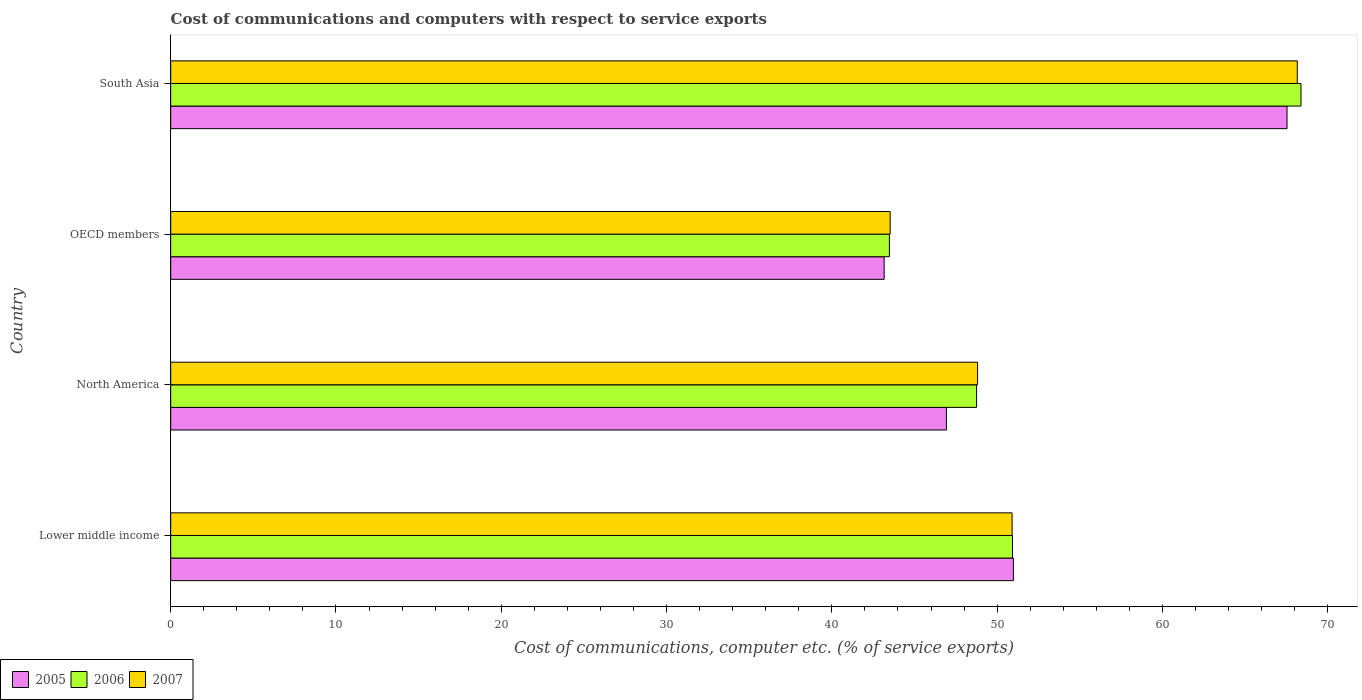How many different coloured bars are there?
Your answer should be compact. 3. How many groups of bars are there?
Provide a short and direct response. 4. Are the number of bars per tick equal to the number of legend labels?
Offer a terse response. Yes. What is the label of the 4th group of bars from the top?
Your answer should be compact. Lower middle income. What is the cost of communications and computers in 2005 in Lower middle income?
Give a very brief answer. 50.99. Across all countries, what is the maximum cost of communications and computers in 2007?
Offer a terse response. 68.16. Across all countries, what is the minimum cost of communications and computers in 2007?
Provide a succinct answer. 43.53. In which country was the cost of communications and computers in 2006 maximum?
Your response must be concise. South Asia. In which country was the cost of communications and computers in 2006 minimum?
Your answer should be compact. OECD members. What is the total cost of communications and computers in 2006 in the graph?
Offer a terse response. 211.55. What is the difference between the cost of communications and computers in 2005 in Lower middle income and that in North America?
Provide a succinct answer. 4.05. What is the difference between the cost of communications and computers in 2005 in Lower middle income and the cost of communications and computers in 2006 in OECD members?
Offer a terse response. 7.5. What is the average cost of communications and computers in 2006 per country?
Your answer should be compact. 52.89. What is the difference between the cost of communications and computers in 2007 and cost of communications and computers in 2005 in Lower middle income?
Provide a succinct answer. -0.08. What is the ratio of the cost of communications and computers in 2007 in Lower middle income to that in OECD members?
Your answer should be compact. 1.17. Is the cost of communications and computers in 2005 in North America less than that in South Asia?
Your answer should be compact. Yes. Is the difference between the cost of communications and computers in 2007 in OECD members and South Asia greater than the difference between the cost of communications and computers in 2005 in OECD members and South Asia?
Provide a succinct answer. No. What is the difference between the highest and the second highest cost of communications and computers in 2007?
Offer a very short reply. 17.25. What is the difference between the highest and the lowest cost of communications and computers in 2005?
Give a very brief answer. 24.37. Is the sum of the cost of communications and computers in 2006 in Lower middle income and South Asia greater than the maximum cost of communications and computers in 2005 across all countries?
Offer a very short reply. Yes. What does the 2nd bar from the bottom in Lower middle income represents?
Provide a short and direct response. 2006. How many bars are there?
Your answer should be very brief. 12. Are all the bars in the graph horizontal?
Ensure brevity in your answer.  Yes. How many countries are there in the graph?
Provide a succinct answer. 4. What is the difference between two consecutive major ticks on the X-axis?
Keep it short and to the point. 10. Are the values on the major ticks of X-axis written in scientific E-notation?
Provide a succinct answer. No. Does the graph contain any zero values?
Offer a very short reply. No. What is the title of the graph?
Offer a very short reply. Cost of communications and computers with respect to service exports. Does "2011" appear as one of the legend labels in the graph?
Provide a short and direct response. No. What is the label or title of the X-axis?
Offer a very short reply. Cost of communications, computer etc. (% of service exports). What is the label or title of the Y-axis?
Your answer should be compact. Country. What is the Cost of communications, computer etc. (% of service exports) in 2005 in Lower middle income?
Offer a terse response. 50.99. What is the Cost of communications, computer etc. (% of service exports) in 2006 in Lower middle income?
Keep it short and to the point. 50.93. What is the Cost of communications, computer etc. (% of service exports) of 2007 in Lower middle income?
Your answer should be very brief. 50.91. What is the Cost of communications, computer etc. (% of service exports) in 2005 in North America?
Your answer should be compact. 46.93. What is the Cost of communications, computer etc. (% of service exports) in 2006 in North America?
Your response must be concise. 48.76. What is the Cost of communications, computer etc. (% of service exports) in 2007 in North America?
Make the answer very short. 48.82. What is the Cost of communications, computer etc. (% of service exports) in 2005 in OECD members?
Your answer should be very brief. 43.17. What is the Cost of communications, computer etc. (% of service exports) of 2006 in OECD members?
Make the answer very short. 43.48. What is the Cost of communications, computer etc. (% of service exports) in 2007 in OECD members?
Provide a succinct answer. 43.53. What is the Cost of communications, computer etc. (% of service exports) in 2005 in South Asia?
Make the answer very short. 67.54. What is the Cost of communications, computer etc. (% of service exports) of 2006 in South Asia?
Your response must be concise. 68.39. What is the Cost of communications, computer etc. (% of service exports) in 2007 in South Asia?
Your answer should be very brief. 68.16. Across all countries, what is the maximum Cost of communications, computer etc. (% of service exports) in 2005?
Offer a very short reply. 67.54. Across all countries, what is the maximum Cost of communications, computer etc. (% of service exports) of 2006?
Your response must be concise. 68.39. Across all countries, what is the maximum Cost of communications, computer etc. (% of service exports) of 2007?
Ensure brevity in your answer.  68.16. Across all countries, what is the minimum Cost of communications, computer etc. (% of service exports) in 2005?
Provide a succinct answer. 43.17. Across all countries, what is the minimum Cost of communications, computer etc. (% of service exports) in 2006?
Keep it short and to the point. 43.48. Across all countries, what is the minimum Cost of communications, computer etc. (% of service exports) in 2007?
Provide a succinct answer. 43.53. What is the total Cost of communications, computer etc. (% of service exports) of 2005 in the graph?
Provide a short and direct response. 208.63. What is the total Cost of communications, computer etc. (% of service exports) of 2006 in the graph?
Ensure brevity in your answer.  211.55. What is the total Cost of communications, computer etc. (% of service exports) of 2007 in the graph?
Your response must be concise. 211.41. What is the difference between the Cost of communications, computer etc. (% of service exports) in 2005 in Lower middle income and that in North America?
Your answer should be very brief. 4.05. What is the difference between the Cost of communications, computer etc. (% of service exports) of 2006 in Lower middle income and that in North America?
Offer a very short reply. 2.17. What is the difference between the Cost of communications, computer etc. (% of service exports) in 2007 in Lower middle income and that in North America?
Your answer should be compact. 2.09. What is the difference between the Cost of communications, computer etc. (% of service exports) in 2005 in Lower middle income and that in OECD members?
Provide a succinct answer. 7.82. What is the difference between the Cost of communications, computer etc. (% of service exports) in 2006 in Lower middle income and that in OECD members?
Provide a succinct answer. 7.45. What is the difference between the Cost of communications, computer etc. (% of service exports) in 2007 in Lower middle income and that in OECD members?
Provide a short and direct response. 7.38. What is the difference between the Cost of communications, computer etc. (% of service exports) of 2005 in Lower middle income and that in South Asia?
Give a very brief answer. -16.55. What is the difference between the Cost of communications, computer etc. (% of service exports) in 2006 in Lower middle income and that in South Asia?
Your response must be concise. -17.45. What is the difference between the Cost of communications, computer etc. (% of service exports) in 2007 in Lower middle income and that in South Asia?
Provide a succinct answer. -17.25. What is the difference between the Cost of communications, computer etc. (% of service exports) of 2005 in North America and that in OECD members?
Give a very brief answer. 3.77. What is the difference between the Cost of communications, computer etc. (% of service exports) of 2006 in North America and that in OECD members?
Provide a short and direct response. 5.28. What is the difference between the Cost of communications, computer etc. (% of service exports) of 2007 in North America and that in OECD members?
Offer a very short reply. 5.29. What is the difference between the Cost of communications, computer etc. (% of service exports) of 2005 in North America and that in South Asia?
Your answer should be very brief. -20.61. What is the difference between the Cost of communications, computer etc. (% of service exports) of 2006 in North America and that in South Asia?
Your response must be concise. -19.63. What is the difference between the Cost of communications, computer etc. (% of service exports) in 2007 in North America and that in South Asia?
Your response must be concise. -19.34. What is the difference between the Cost of communications, computer etc. (% of service exports) of 2005 in OECD members and that in South Asia?
Your answer should be very brief. -24.37. What is the difference between the Cost of communications, computer etc. (% of service exports) in 2006 in OECD members and that in South Asia?
Make the answer very short. -24.9. What is the difference between the Cost of communications, computer etc. (% of service exports) of 2007 in OECD members and that in South Asia?
Your answer should be compact. -24.63. What is the difference between the Cost of communications, computer etc. (% of service exports) in 2005 in Lower middle income and the Cost of communications, computer etc. (% of service exports) in 2006 in North America?
Offer a terse response. 2.23. What is the difference between the Cost of communications, computer etc. (% of service exports) of 2005 in Lower middle income and the Cost of communications, computer etc. (% of service exports) of 2007 in North America?
Ensure brevity in your answer.  2.17. What is the difference between the Cost of communications, computer etc. (% of service exports) in 2006 in Lower middle income and the Cost of communications, computer etc. (% of service exports) in 2007 in North America?
Provide a short and direct response. 2.11. What is the difference between the Cost of communications, computer etc. (% of service exports) in 2005 in Lower middle income and the Cost of communications, computer etc. (% of service exports) in 2006 in OECD members?
Provide a short and direct response. 7.5. What is the difference between the Cost of communications, computer etc. (% of service exports) in 2005 in Lower middle income and the Cost of communications, computer etc. (% of service exports) in 2007 in OECD members?
Offer a terse response. 7.46. What is the difference between the Cost of communications, computer etc. (% of service exports) in 2006 in Lower middle income and the Cost of communications, computer etc. (% of service exports) in 2007 in OECD members?
Provide a short and direct response. 7.4. What is the difference between the Cost of communications, computer etc. (% of service exports) in 2005 in Lower middle income and the Cost of communications, computer etc. (% of service exports) in 2006 in South Asia?
Ensure brevity in your answer.  -17.4. What is the difference between the Cost of communications, computer etc. (% of service exports) in 2005 in Lower middle income and the Cost of communications, computer etc. (% of service exports) in 2007 in South Asia?
Offer a terse response. -17.18. What is the difference between the Cost of communications, computer etc. (% of service exports) of 2006 in Lower middle income and the Cost of communications, computer etc. (% of service exports) of 2007 in South Asia?
Provide a short and direct response. -17.23. What is the difference between the Cost of communications, computer etc. (% of service exports) of 2005 in North America and the Cost of communications, computer etc. (% of service exports) of 2006 in OECD members?
Keep it short and to the point. 3.45. What is the difference between the Cost of communications, computer etc. (% of service exports) in 2005 in North America and the Cost of communications, computer etc. (% of service exports) in 2007 in OECD members?
Offer a terse response. 3.41. What is the difference between the Cost of communications, computer etc. (% of service exports) in 2006 in North America and the Cost of communications, computer etc. (% of service exports) in 2007 in OECD members?
Give a very brief answer. 5.23. What is the difference between the Cost of communications, computer etc. (% of service exports) in 2005 in North America and the Cost of communications, computer etc. (% of service exports) in 2006 in South Asia?
Offer a terse response. -21.45. What is the difference between the Cost of communications, computer etc. (% of service exports) in 2005 in North America and the Cost of communications, computer etc. (% of service exports) in 2007 in South Asia?
Your answer should be compact. -21.23. What is the difference between the Cost of communications, computer etc. (% of service exports) of 2006 in North America and the Cost of communications, computer etc. (% of service exports) of 2007 in South Asia?
Provide a succinct answer. -19.4. What is the difference between the Cost of communications, computer etc. (% of service exports) of 2005 in OECD members and the Cost of communications, computer etc. (% of service exports) of 2006 in South Asia?
Make the answer very short. -25.22. What is the difference between the Cost of communications, computer etc. (% of service exports) in 2005 in OECD members and the Cost of communications, computer etc. (% of service exports) in 2007 in South Asia?
Keep it short and to the point. -24.99. What is the difference between the Cost of communications, computer etc. (% of service exports) in 2006 in OECD members and the Cost of communications, computer etc. (% of service exports) in 2007 in South Asia?
Give a very brief answer. -24.68. What is the average Cost of communications, computer etc. (% of service exports) in 2005 per country?
Your answer should be very brief. 52.16. What is the average Cost of communications, computer etc. (% of service exports) in 2006 per country?
Offer a very short reply. 52.89. What is the average Cost of communications, computer etc. (% of service exports) in 2007 per country?
Offer a terse response. 52.85. What is the difference between the Cost of communications, computer etc. (% of service exports) in 2005 and Cost of communications, computer etc. (% of service exports) in 2006 in Lower middle income?
Your response must be concise. 0.06. What is the difference between the Cost of communications, computer etc. (% of service exports) in 2005 and Cost of communications, computer etc. (% of service exports) in 2007 in Lower middle income?
Keep it short and to the point. 0.08. What is the difference between the Cost of communications, computer etc. (% of service exports) of 2006 and Cost of communications, computer etc. (% of service exports) of 2007 in Lower middle income?
Your answer should be very brief. 0.02. What is the difference between the Cost of communications, computer etc. (% of service exports) in 2005 and Cost of communications, computer etc. (% of service exports) in 2006 in North America?
Offer a terse response. -1.82. What is the difference between the Cost of communications, computer etc. (% of service exports) in 2005 and Cost of communications, computer etc. (% of service exports) in 2007 in North America?
Offer a very short reply. -1.88. What is the difference between the Cost of communications, computer etc. (% of service exports) in 2006 and Cost of communications, computer etc. (% of service exports) in 2007 in North America?
Ensure brevity in your answer.  -0.06. What is the difference between the Cost of communications, computer etc. (% of service exports) of 2005 and Cost of communications, computer etc. (% of service exports) of 2006 in OECD members?
Your answer should be compact. -0.32. What is the difference between the Cost of communications, computer etc. (% of service exports) in 2005 and Cost of communications, computer etc. (% of service exports) in 2007 in OECD members?
Your answer should be compact. -0.36. What is the difference between the Cost of communications, computer etc. (% of service exports) of 2006 and Cost of communications, computer etc. (% of service exports) of 2007 in OECD members?
Your answer should be very brief. -0.05. What is the difference between the Cost of communications, computer etc. (% of service exports) in 2005 and Cost of communications, computer etc. (% of service exports) in 2006 in South Asia?
Make the answer very short. -0.84. What is the difference between the Cost of communications, computer etc. (% of service exports) in 2005 and Cost of communications, computer etc. (% of service exports) in 2007 in South Asia?
Offer a terse response. -0.62. What is the difference between the Cost of communications, computer etc. (% of service exports) of 2006 and Cost of communications, computer etc. (% of service exports) of 2007 in South Asia?
Your answer should be very brief. 0.22. What is the ratio of the Cost of communications, computer etc. (% of service exports) in 2005 in Lower middle income to that in North America?
Give a very brief answer. 1.09. What is the ratio of the Cost of communications, computer etc. (% of service exports) of 2006 in Lower middle income to that in North America?
Offer a very short reply. 1.04. What is the ratio of the Cost of communications, computer etc. (% of service exports) of 2007 in Lower middle income to that in North America?
Make the answer very short. 1.04. What is the ratio of the Cost of communications, computer etc. (% of service exports) in 2005 in Lower middle income to that in OECD members?
Ensure brevity in your answer.  1.18. What is the ratio of the Cost of communications, computer etc. (% of service exports) in 2006 in Lower middle income to that in OECD members?
Provide a short and direct response. 1.17. What is the ratio of the Cost of communications, computer etc. (% of service exports) of 2007 in Lower middle income to that in OECD members?
Keep it short and to the point. 1.17. What is the ratio of the Cost of communications, computer etc. (% of service exports) of 2005 in Lower middle income to that in South Asia?
Your answer should be compact. 0.75. What is the ratio of the Cost of communications, computer etc. (% of service exports) of 2006 in Lower middle income to that in South Asia?
Your response must be concise. 0.74. What is the ratio of the Cost of communications, computer etc. (% of service exports) in 2007 in Lower middle income to that in South Asia?
Your response must be concise. 0.75. What is the ratio of the Cost of communications, computer etc. (% of service exports) in 2005 in North America to that in OECD members?
Provide a succinct answer. 1.09. What is the ratio of the Cost of communications, computer etc. (% of service exports) in 2006 in North America to that in OECD members?
Your answer should be compact. 1.12. What is the ratio of the Cost of communications, computer etc. (% of service exports) in 2007 in North America to that in OECD members?
Your answer should be compact. 1.12. What is the ratio of the Cost of communications, computer etc. (% of service exports) of 2005 in North America to that in South Asia?
Provide a short and direct response. 0.69. What is the ratio of the Cost of communications, computer etc. (% of service exports) of 2006 in North America to that in South Asia?
Keep it short and to the point. 0.71. What is the ratio of the Cost of communications, computer etc. (% of service exports) of 2007 in North America to that in South Asia?
Make the answer very short. 0.72. What is the ratio of the Cost of communications, computer etc. (% of service exports) of 2005 in OECD members to that in South Asia?
Provide a succinct answer. 0.64. What is the ratio of the Cost of communications, computer etc. (% of service exports) in 2006 in OECD members to that in South Asia?
Provide a short and direct response. 0.64. What is the ratio of the Cost of communications, computer etc. (% of service exports) of 2007 in OECD members to that in South Asia?
Your answer should be compact. 0.64. What is the difference between the highest and the second highest Cost of communications, computer etc. (% of service exports) of 2005?
Your answer should be very brief. 16.55. What is the difference between the highest and the second highest Cost of communications, computer etc. (% of service exports) of 2006?
Your answer should be very brief. 17.45. What is the difference between the highest and the second highest Cost of communications, computer etc. (% of service exports) of 2007?
Offer a terse response. 17.25. What is the difference between the highest and the lowest Cost of communications, computer etc. (% of service exports) of 2005?
Offer a terse response. 24.37. What is the difference between the highest and the lowest Cost of communications, computer etc. (% of service exports) of 2006?
Offer a terse response. 24.9. What is the difference between the highest and the lowest Cost of communications, computer etc. (% of service exports) in 2007?
Keep it short and to the point. 24.63. 